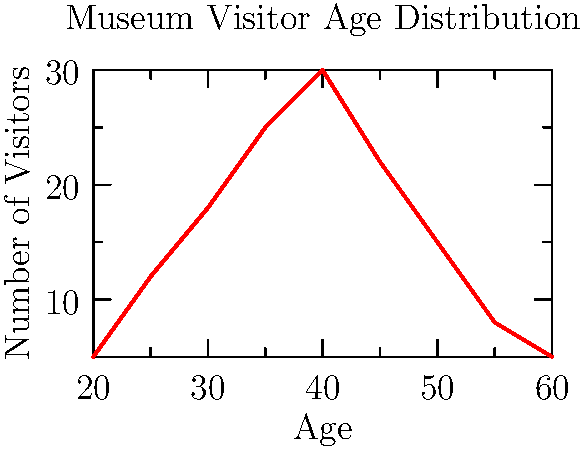Based on the graph showing the age distribution of museum visitors, what machine learning approach would be most suitable for estimating visitor age demographics from surveillance camera footage, and why? To answer this question, let's analyze the problem and consider suitable machine learning approaches:

1. Problem type: We need to estimate ages from visual data (surveillance footage), which is a regression problem.

2. Data characteristics:
   - Input: Images from surveillance cameras
   - Output: Continuous age values

3. Suitable ML approaches:
   a) Convolutional Neural Networks (CNNs):
      - Excellent for image processing tasks
      - Can learn hierarchical features from raw pixel data

   b) Transfer Learning with pre-trained models:
      - Utilize models pre-trained on large datasets (e.g., ImageNet)
      - Fine-tune for age estimation task

   c) Ensemble methods:
      - Combine multiple models for improved accuracy
      - Can help mitigate bias and reduce errors

4. Best approach: CNN with transfer learning
   Reasons:
   - CNNs are specifically designed for image processing
   - Transfer learning allows leveraging pre-existing knowledge
   - Can be fine-tuned with limited museum-specific data
   - Capable of handling variations in lighting, angles, and image quality

5. Implementation steps:
   a) Select a pre-trained CNN (e.g., ResNet, VGGNet)
   b) Replace the final layers with age regression layers
   c) Fine-tune the model on a dataset of labeled museum visitor images
   d) Use the trained model to estimate ages from surveillance footage
   e) Aggregate results to create age demographic estimates

This approach would provide accurate age estimations while being efficient in terms of data requirements and training time.
Answer: CNN with transfer learning 